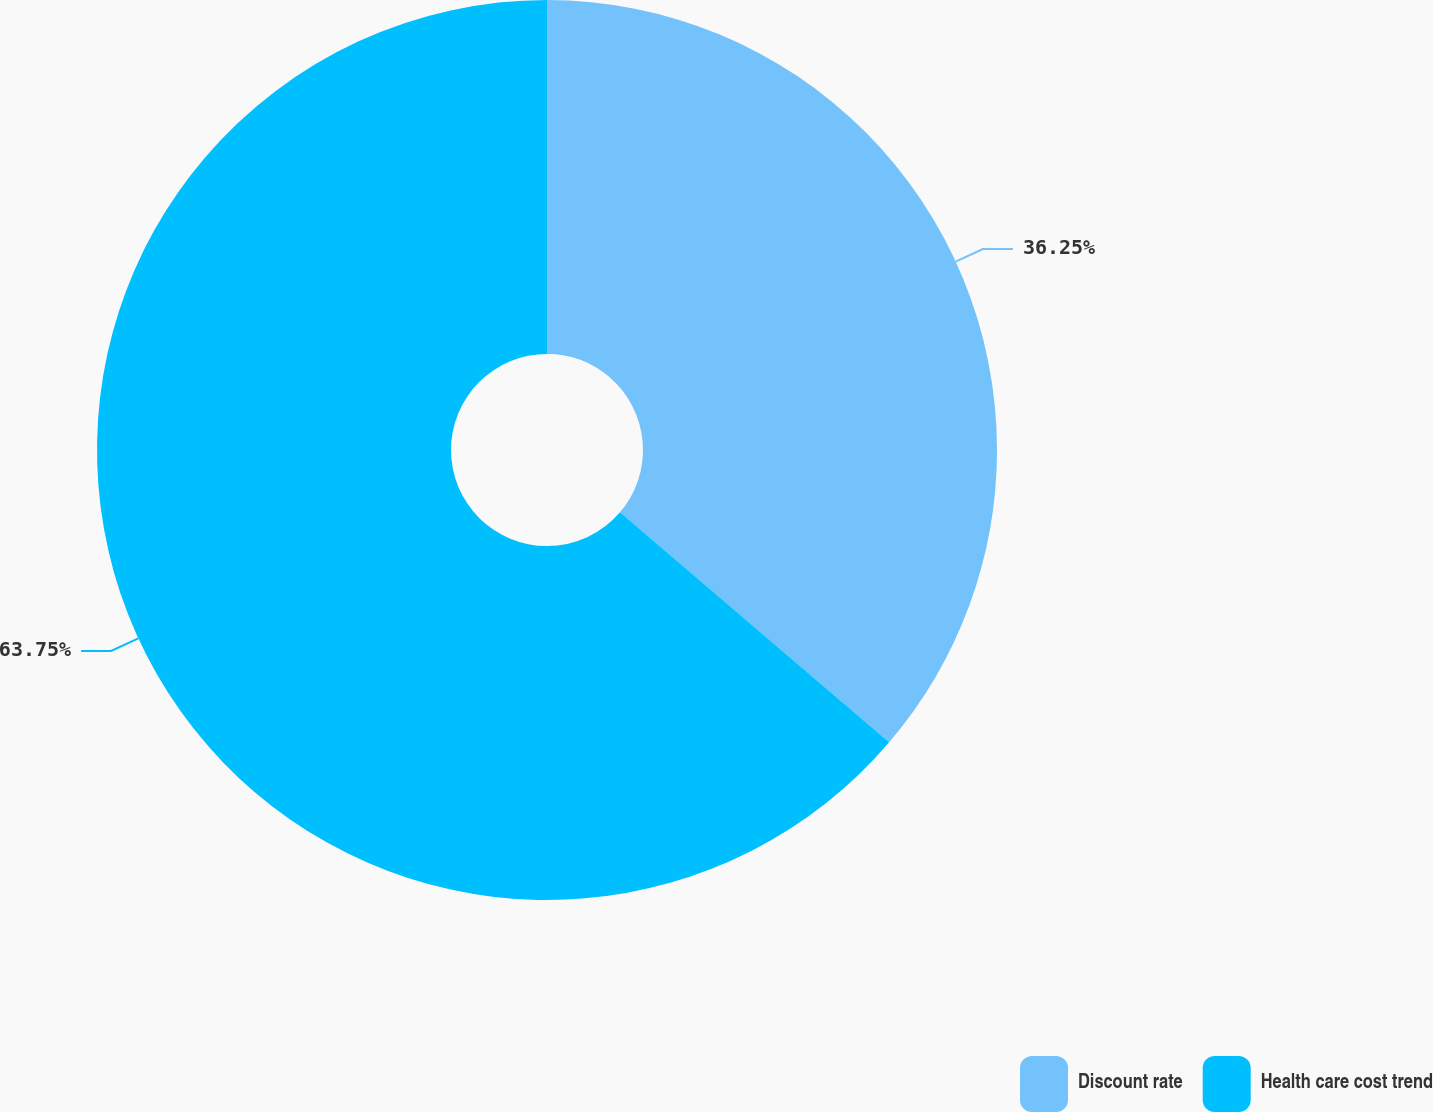<chart> <loc_0><loc_0><loc_500><loc_500><pie_chart><fcel>Discount rate<fcel>Health care cost trend<nl><fcel>36.25%<fcel>63.75%<nl></chart> 